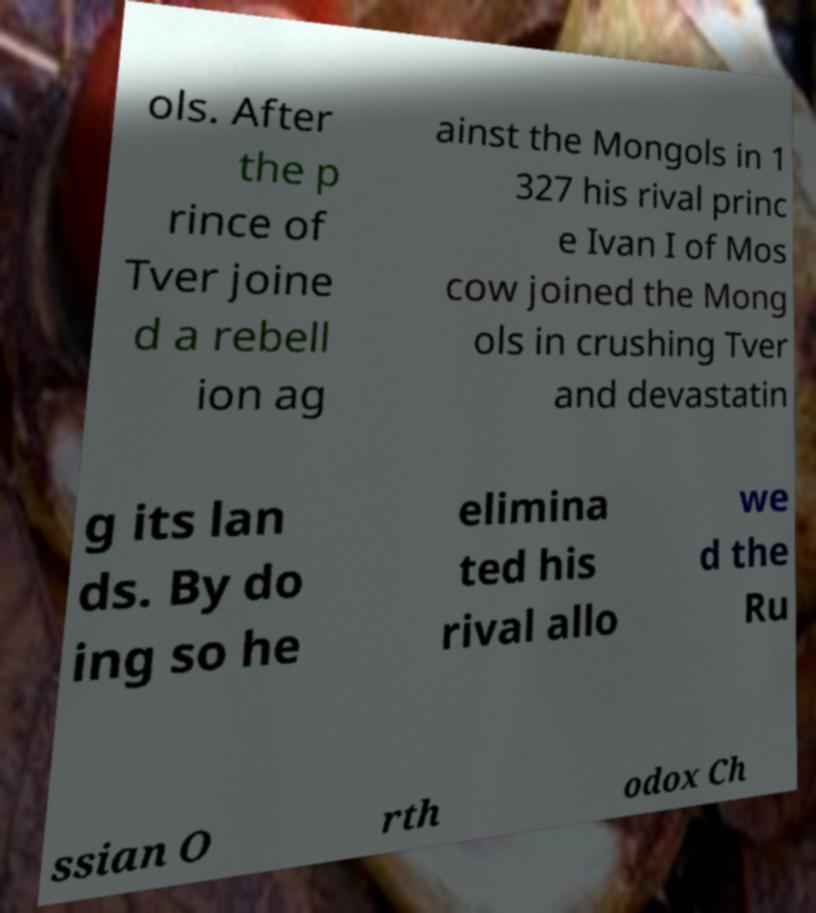Please identify and transcribe the text found in this image. ols. After the p rince of Tver joine d a rebell ion ag ainst the Mongols in 1 327 his rival princ e Ivan I of Mos cow joined the Mong ols in crushing Tver and devastatin g its lan ds. By do ing so he elimina ted his rival allo we d the Ru ssian O rth odox Ch 